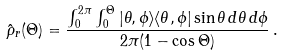Convert formula to latex. <formula><loc_0><loc_0><loc_500><loc_500>\hat { \rho } _ { r } ( \Theta ) = \frac { \int _ { 0 } ^ { 2 \pi } \int _ { 0 } ^ { \Theta } | \theta , \phi \rangle \langle \theta , \phi | \sin \theta \, d \theta \, d \phi } { 2 \pi ( 1 - \cos \Theta ) } \, .</formula> 